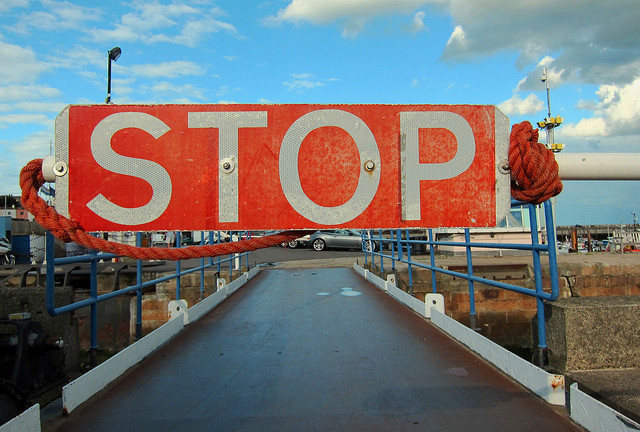What is the main subject of the image? The main subject of the image is the prominent stop sign situated at the entrance to a bridge or dock under a bright blue sky.  Can you tell me what time of day this photo was taken? Given the shadows and quality of light, it seems like the photo was taken during the late afternoon hours. 